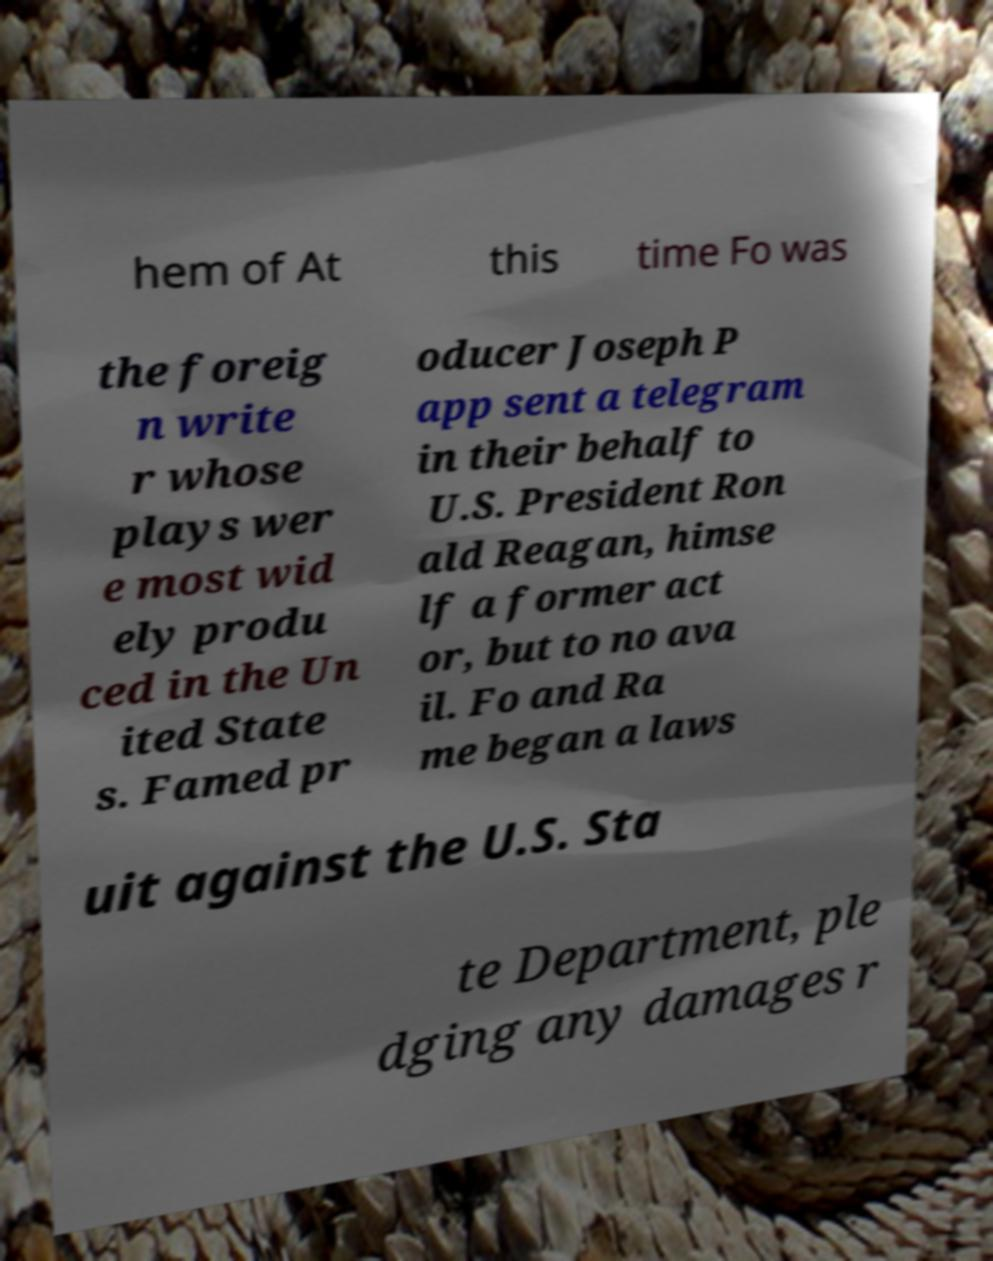I need the written content from this picture converted into text. Can you do that? hem of At this time Fo was the foreig n write r whose plays wer e most wid ely produ ced in the Un ited State s. Famed pr oducer Joseph P app sent a telegram in their behalf to U.S. President Ron ald Reagan, himse lf a former act or, but to no ava il. Fo and Ra me began a laws uit against the U.S. Sta te Department, ple dging any damages r 